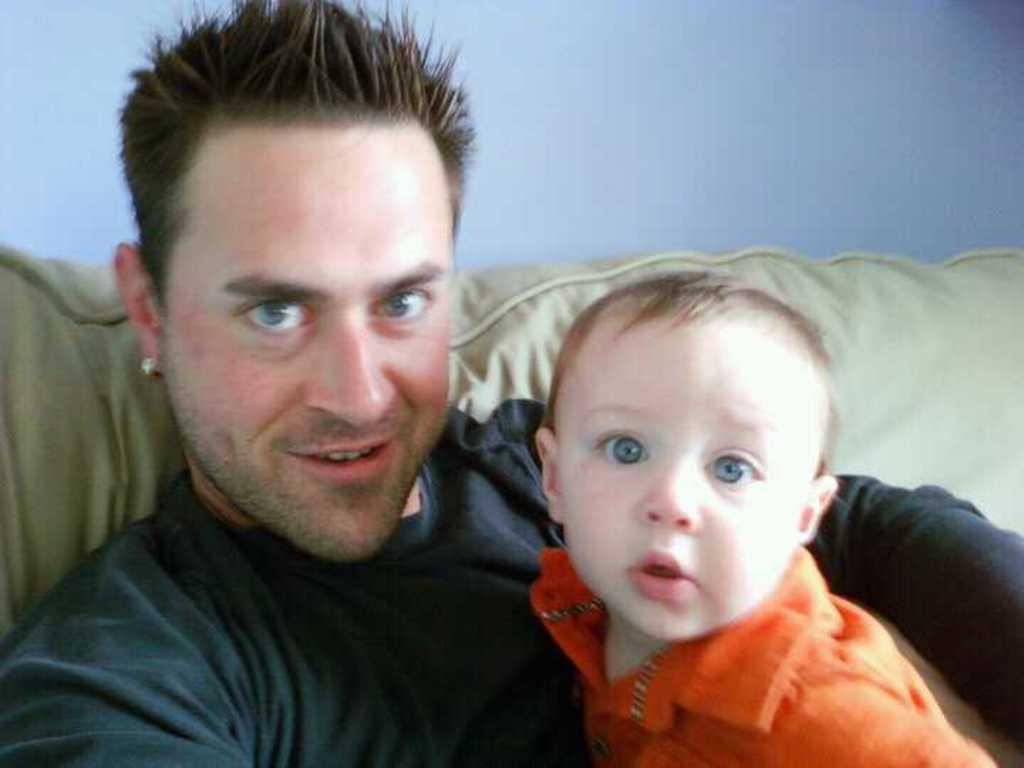Who is present in the image? There is a man in the image. What is the man wearing? The man is wearing a black T-shirt. Who else is present in the image? There is a baby in the image. What is the baby wearing? The baby is wearing an orange shirt. What can be seen in the background of the image? There is a wall in the background of the image. How many poisonous clocks are hanging on the wall in the image? There are no clocks, poisonous or otherwise, present in the image. 